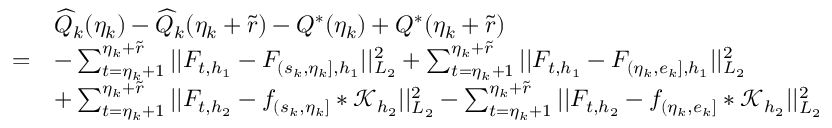<formula> <loc_0><loc_0><loc_500><loc_500>\begin{array} { r l } & { \widehat { Q } _ { k } ( \eta _ { k } ) - \widehat { Q } _ { k } ( \eta _ { k } + \widetilde { r } ) - Q ^ { * } ( \eta _ { k } ) + Q ^ { * } ( \eta _ { k } + \widetilde { r } ) } \\ { = } & { - \sum _ { t = \eta _ { k } + 1 } ^ { \eta _ { k } + \widetilde { r } } | | F _ { t , { h _ { 1 } } } - F _ { ( s _ { k } , \eta _ { k } ] , { h _ { 1 } } } | | _ { L _ { 2 } } ^ { 2 } + \sum _ { t = \eta _ { k } + 1 } ^ { \eta _ { k } + \widetilde { r } } | | F _ { t , { h _ { 1 } } } - F _ { ( \eta _ { k } , e _ { k } ] , { h _ { 1 } } } | | _ { L _ { 2 } } ^ { 2 } } \\ & { + \sum _ { t = \eta _ { k } + 1 } ^ { \eta _ { k } + \widetilde { r } } | | F _ { t , { h _ { 2 } } } - f _ { ( s _ { k } , \eta _ { k } ] } \ast \mathcal { K } _ { { h _ { 2 } } } | | _ { L _ { 2 } } ^ { 2 } - \sum _ { t = \eta _ { k } + 1 } ^ { \eta _ { k } + \widetilde { r } } | | F _ { t , { h _ { 2 } } } - f _ { ( \eta _ { k } , e _ { k } ] } \ast \mathcal { K } _ { h _ { 2 } } | | _ { L _ { 2 } } ^ { 2 } } \end{array}</formula> 